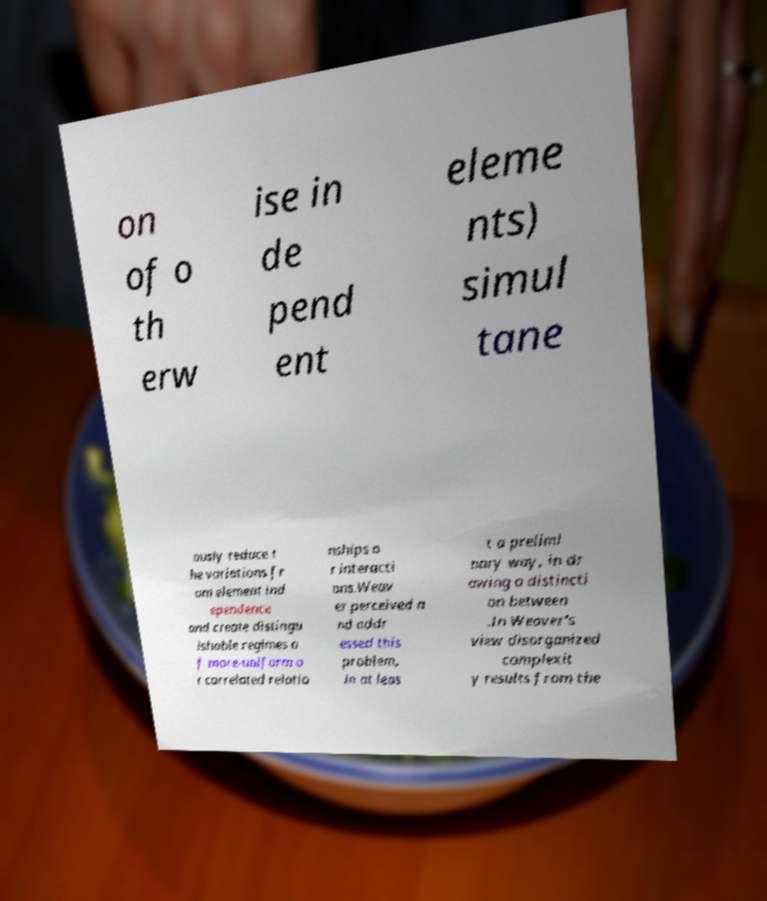For documentation purposes, I need the text within this image transcribed. Could you provide that? on of o th erw ise in de pend ent eleme nts) simul tane ously reduce t he variations fr om element ind ependence and create distingu ishable regimes o f more-uniform o r correlated relatio nships o r interacti ons.Weav er perceived a nd addr essed this problem, in at leas t a prelimi nary way, in dr awing a distincti on between .In Weaver's view disorganized complexit y results from the 